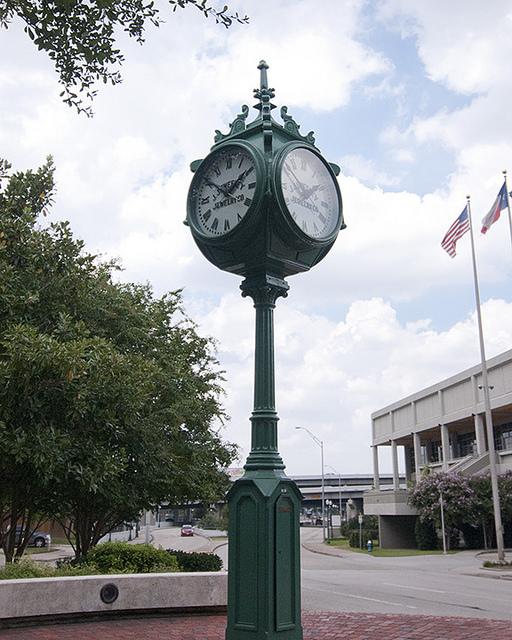How many clocks are shown?
Answer briefly. 2. Where are the flags?
Answer briefly. Right. Is the time the same on both faces?
Quick response, please. Yes. Are there any red bricks in the image?
Give a very brief answer. Yes. 